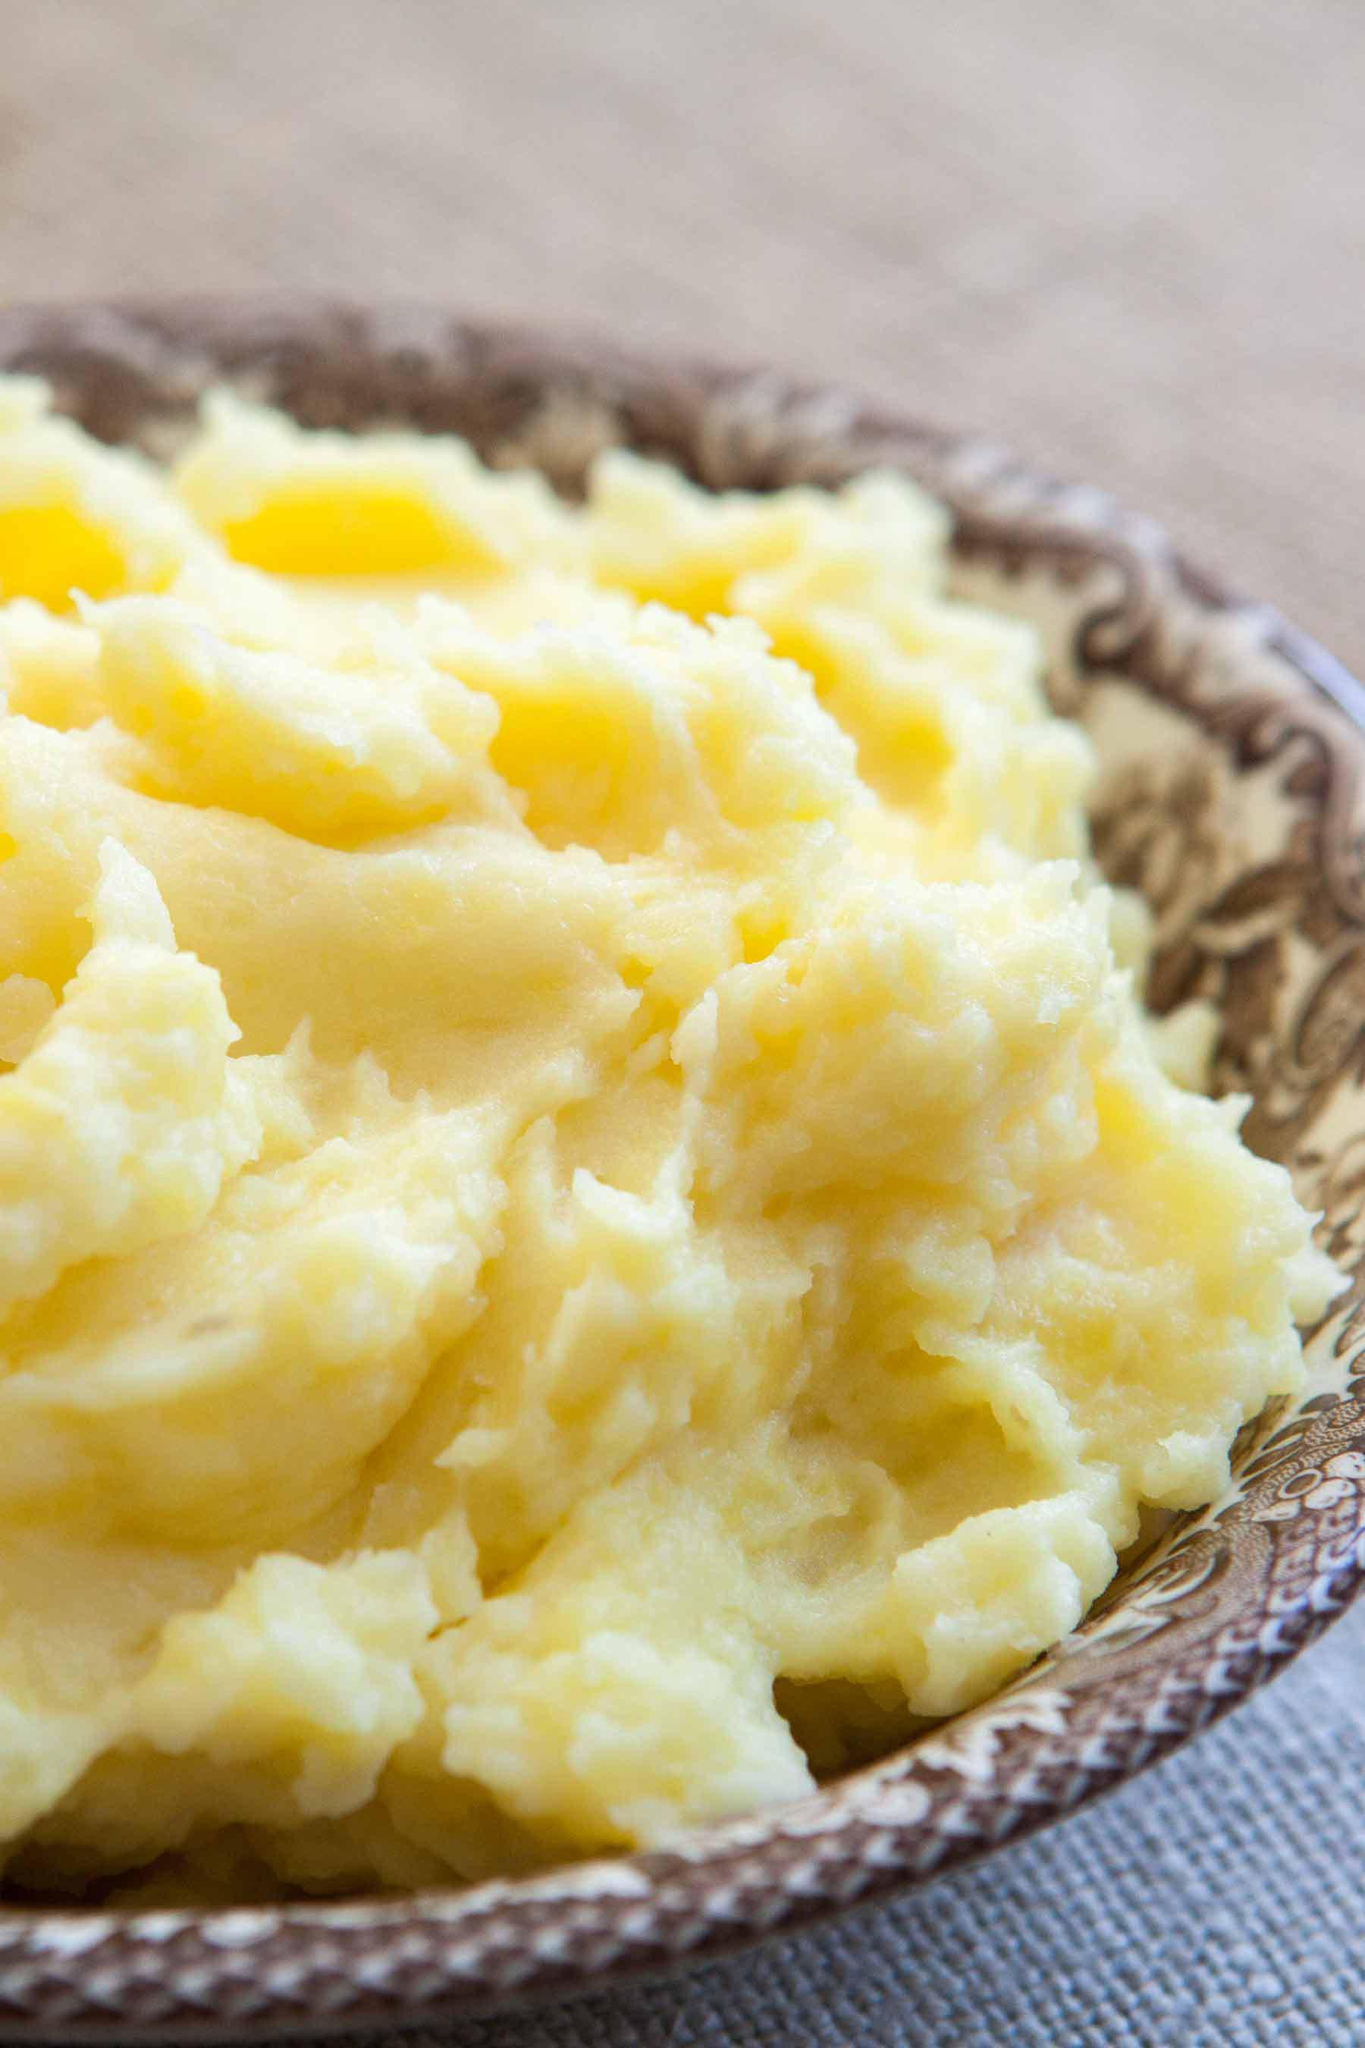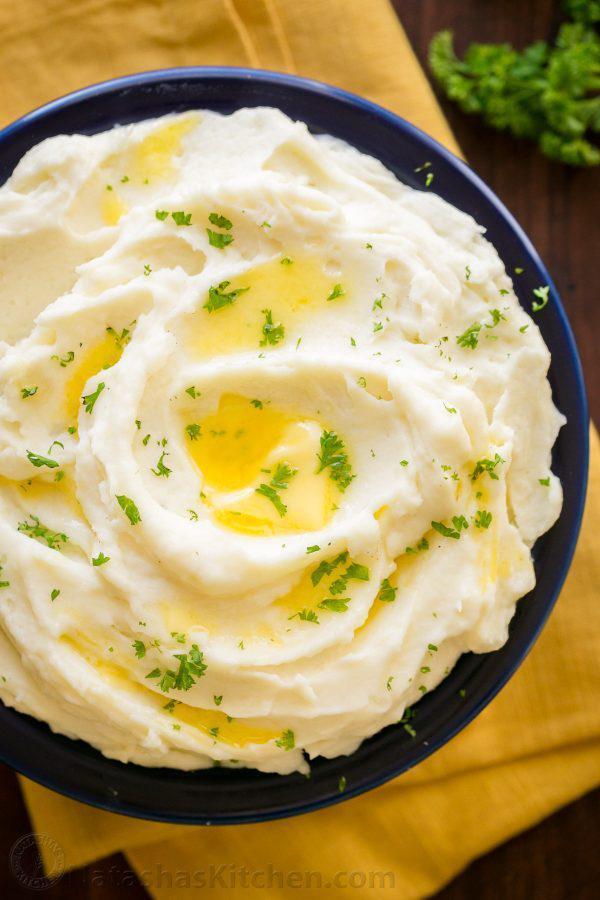The first image is the image on the left, the second image is the image on the right. Considering the images on both sides, is "The image on the right shows a mashed potato on a white bowl." valid? Answer yes or no. No. 